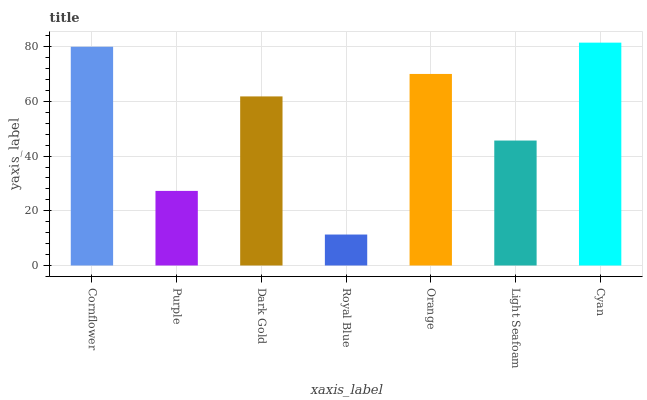Is Royal Blue the minimum?
Answer yes or no. Yes. Is Cyan the maximum?
Answer yes or no. Yes. Is Purple the minimum?
Answer yes or no. No. Is Purple the maximum?
Answer yes or no. No. Is Cornflower greater than Purple?
Answer yes or no. Yes. Is Purple less than Cornflower?
Answer yes or no. Yes. Is Purple greater than Cornflower?
Answer yes or no. No. Is Cornflower less than Purple?
Answer yes or no. No. Is Dark Gold the high median?
Answer yes or no. Yes. Is Dark Gold the low median?
Answer yes or no. Yes. Is Orange the high median?
Answer yes or no. No. Is Cornflower the low median?
Answer yes or no. No. 